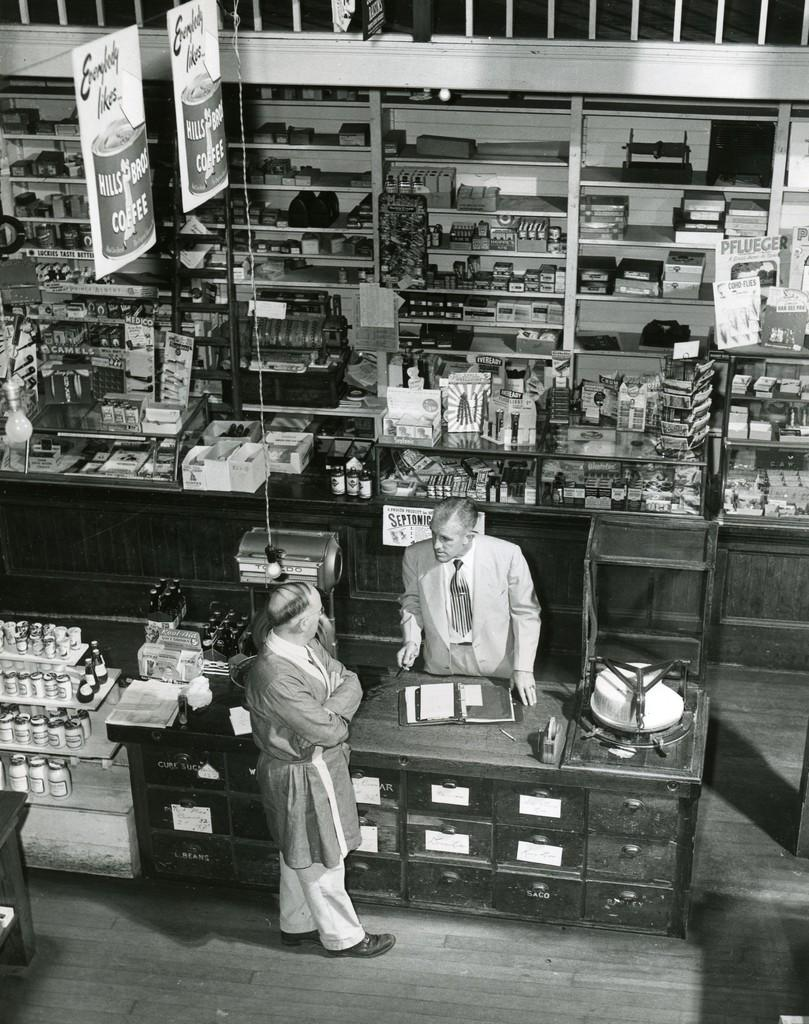<image>
Summarize the visual content of the image. Hills Bros Coffee is advertised on banners hanging above two men in a store. 